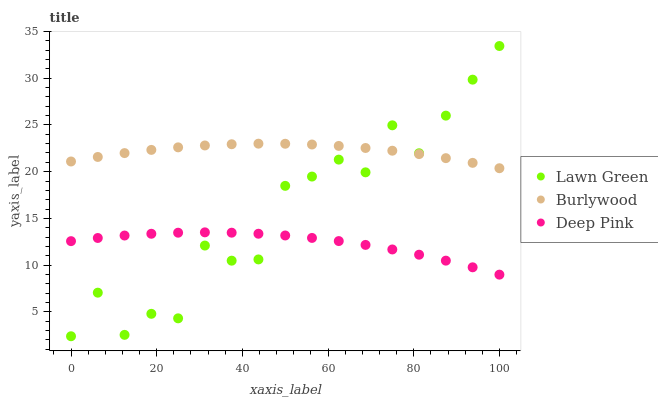Does Deep Pink have the minimum area under the curve?
Answer yes or no. Yes. Does Burlywood have the maximum area under the curve?
Answer yes or no. Yes. Does Lawn Green have the minimum area under the curve?
Answer yes or no. No. Does Lawn Green have the maximum area under the curve?
Answer yes or no. No. Is Burlywood the smoothest?
Answer yes or no. Yes. Is Lawn Green the roughest?
Answer yes or no. Yes. Is Deep Pink the smoothest?
Answer yes or no. No. Is Deep Pink the roughest?
Answer yes or no. No. Does Lawn Green have the lowest value?
Answer yes or no. Yes. Does Deep Pink have the lowest value?
Answer yes or no. No. Does Lawn Green have the highest value?
Answer yes or no. Yes. Does Deep Pink have the highest value?
Answer yes or no. No. Is Deep Pink less than Burlywood?
Answer yes or no. Yes. Is Burlywood greater than Deep Pink?
Answer yes or no. Yes. Does Deep Pink intersect Lawn Green?
Answer yes or no. Yes. Is Deep Pink less than Lawn Green?
Answer yes or no. No. Is Deep Pink greater than Lawn Green?
Answer yes or no. No. Does Deep Pink intersect Burlywood?
Answer yes or no. No. 